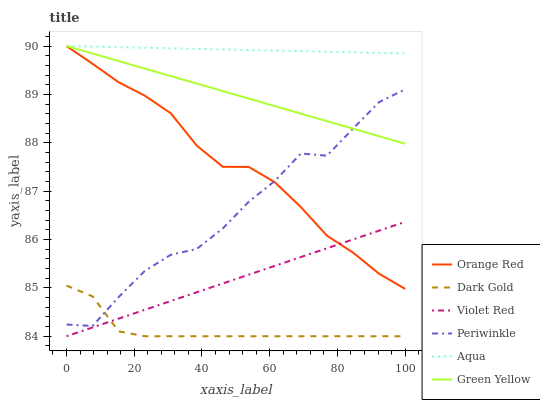Does Dark Gold have the minimum area under the curve?
Answer yes or no. Yes. Does Aqua have the maximum area under the curve?
Answer yes or no. Yes. Does Aqua have the minimum area under the curve?
Answer yes or no. No. Does Dark Gold have the maximum area under the curve?
Answer yes or no. No. Is Green Yellow the smoothest?
Answer yes or no. Yes. Is Periwinkle the roughest?
Answer yes or no. Yes. Is Dark Gold the smoothest?
Answer yes or no. No. Is Dark Gold the roughest?
Answer yes or no. No. Does Violet Red have the lowest value?
Answer yes or no. Yes. Does Aqua have the lowest value?
Answer yes or no. No. Does Orange Red have the highest value?
Answer yes or no. Yes. Does Dark Gold have the highest value?
Answer yes or no. No. Is Periwinkle less than Aqua?
Answer yes or no. Yes. Is Orange Red greater than Dark Gold?
Answer yes or no. Yes. Does Periwinkle intersect Orange Red?
Answer yes or no. Yes. Is Periwinkle less than Orange Red?
Answer yes or no. No. Is Periwinkle greater than Orange Red?
Answer yes or no. No. Does Periwinkle intersect Aqua?
Answer yes or no. No. 